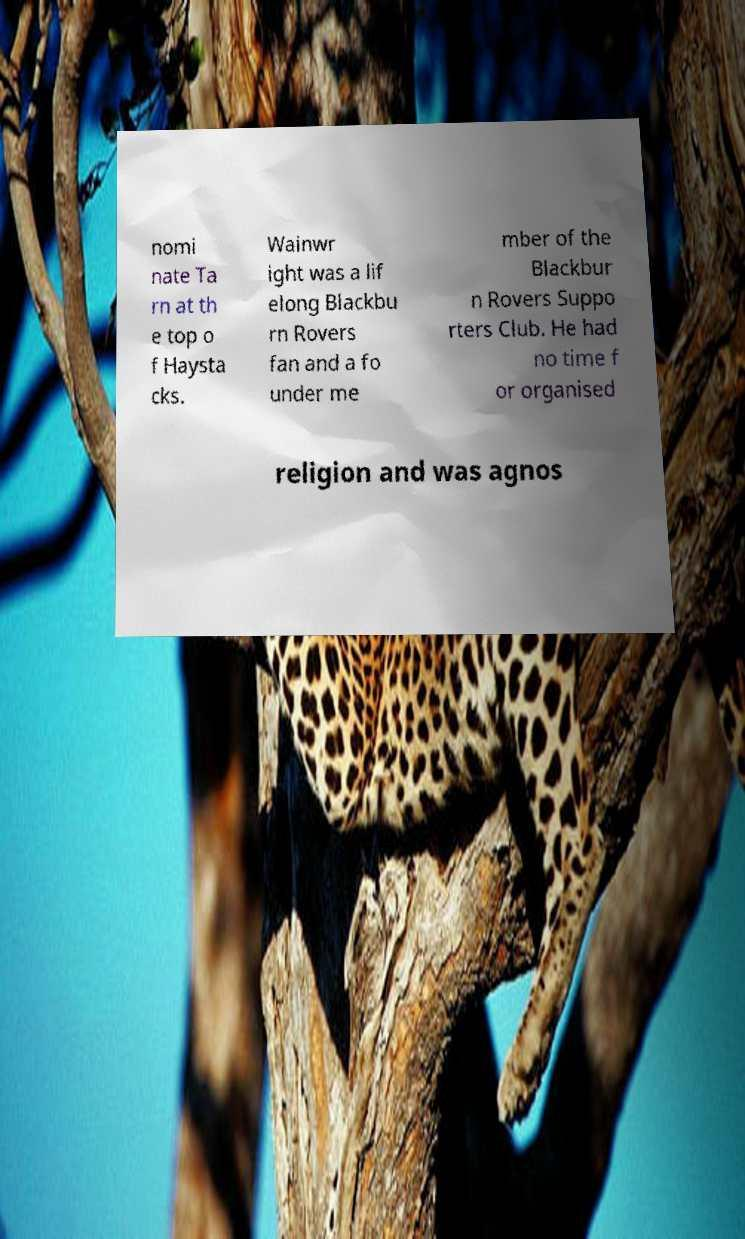Please read and relay the text visible in this image. What does it say? nomi nate Ta rn at th e top o f Haysta cks. Wainwr ight was a lif elong Blackbu rn Rovers fan and a fo under me mber of the Blackbur n Rovers Suppo rters Club. He had no time f or organised religion and was agnos 